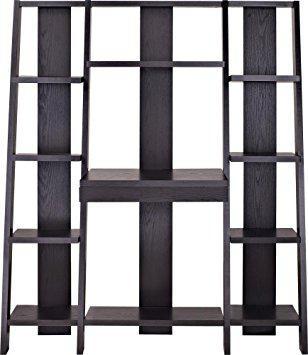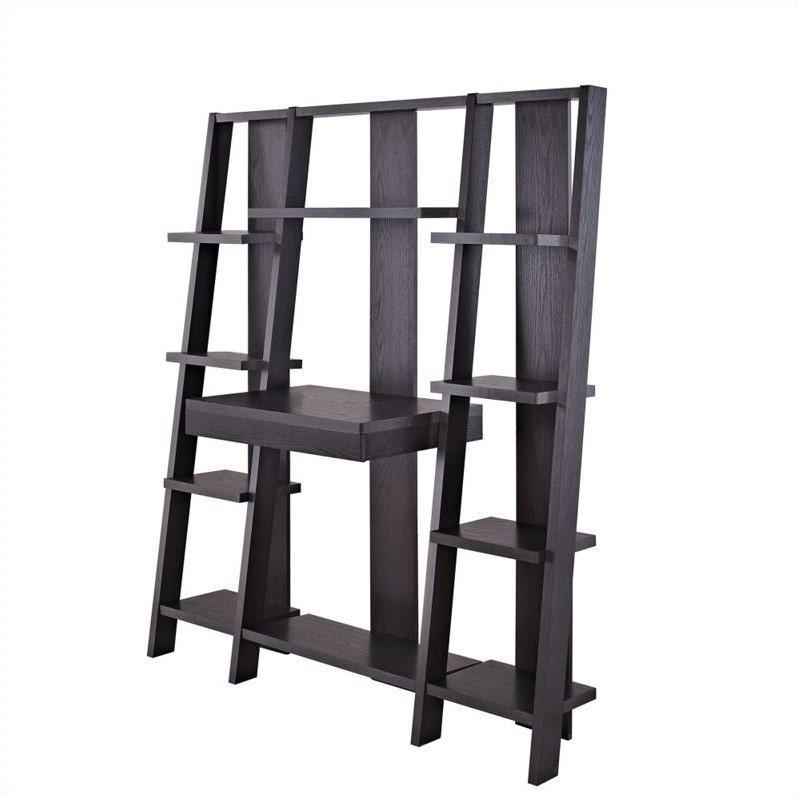The first image is the image on the left, the second image is the image on the right. Analyze the images presented: Is the assertion "Both images contain laptops." valid? Answer yes or no. No. The first image is the image on the left, the second image is the image on the right. Considering the images on both sides, is "A silver colored laptop is sitting on a black desk that is connected to an entertainment center." valid? Answer yes or no. No. 